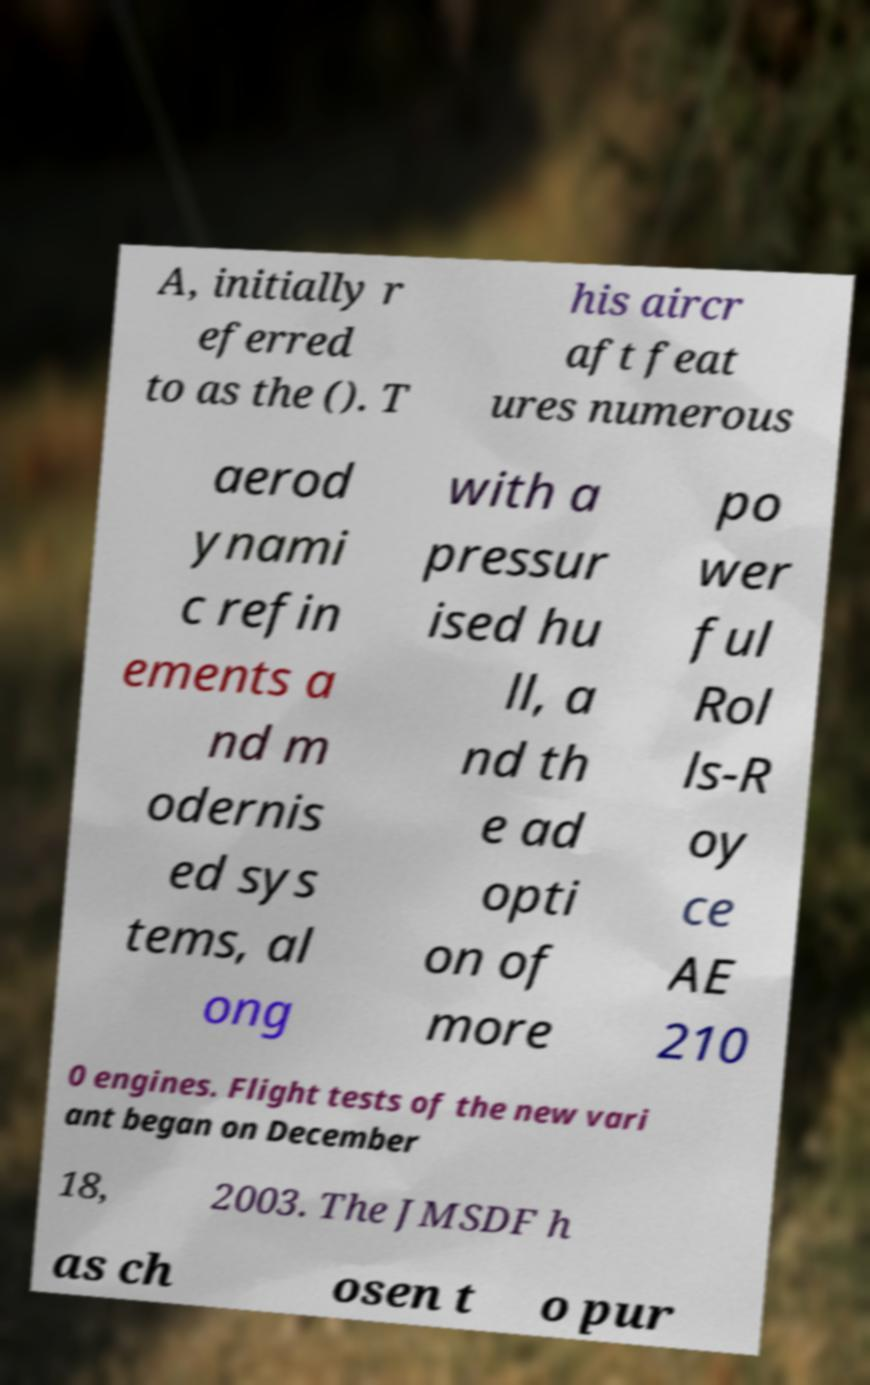Please read and relay the text visible in this image. What does it say? A, initially r eferred to as the (). T his aircr aft feat ures numerous aerod ynami c refin ements a nd m odernis ed sys tems, al ong with a pressur ised hu ll, a nd th e ad opti on of more po wer ful Rol ls-R oy ce AE 210 0 engines. Flight tests of the new vari ant began on December 18, 2003. The JMSDF h as ch osen t o pur 